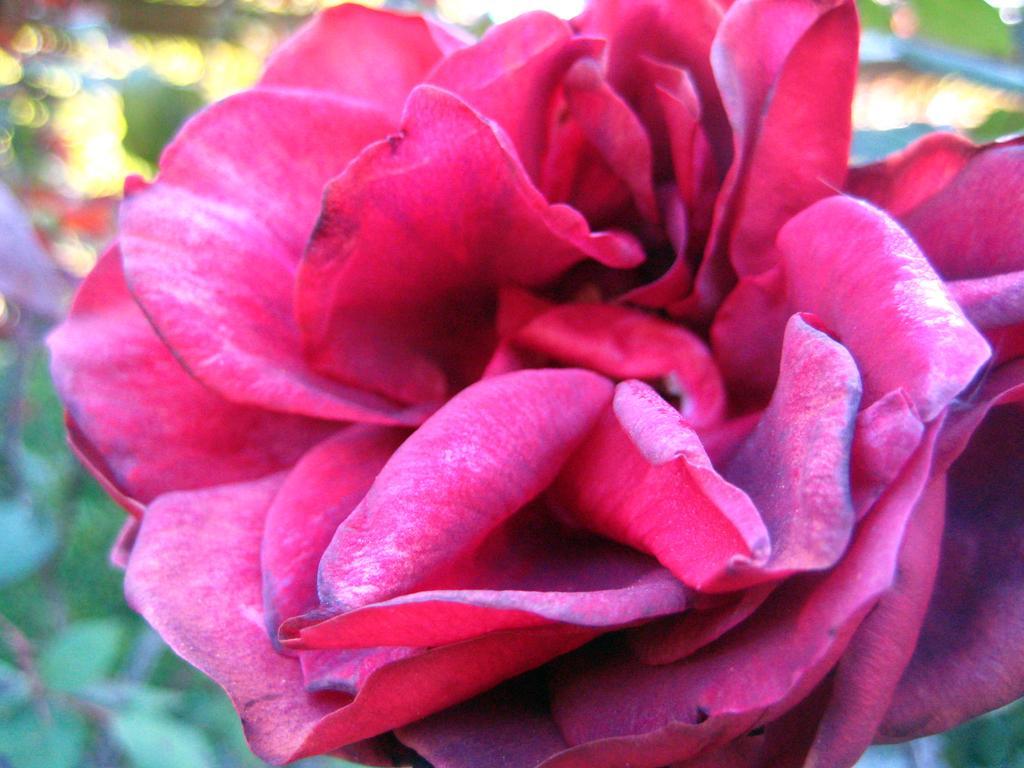Can you describe this image briefly? In this image we can see a flower. Background it is blur. 